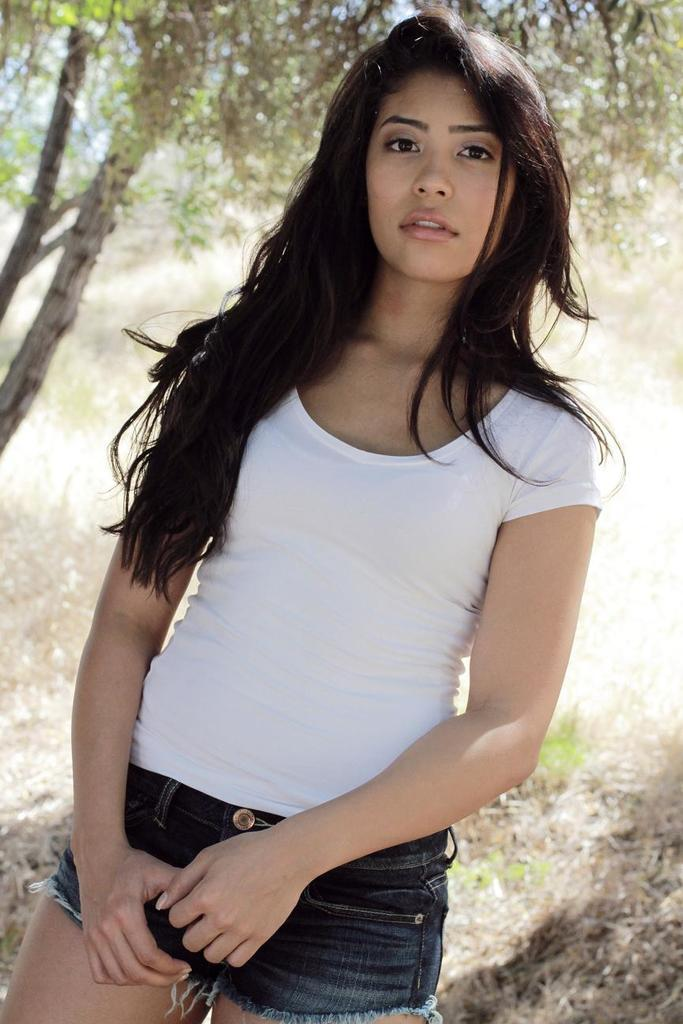Who is the main subject in the image? There is a woman in the image. What is the woman doing in the image? The woman is standing. What is the woman wearing in the image? The woman is wearing a white t-shirt. What type of natural environment is visible in the image? There are trees visible in the image. What is visible in the background of the image? The sky is visible in the image. What type of beef can be seen in the woman's hand in the image? There is no beef present in the image; the woman is not holding any food item. 